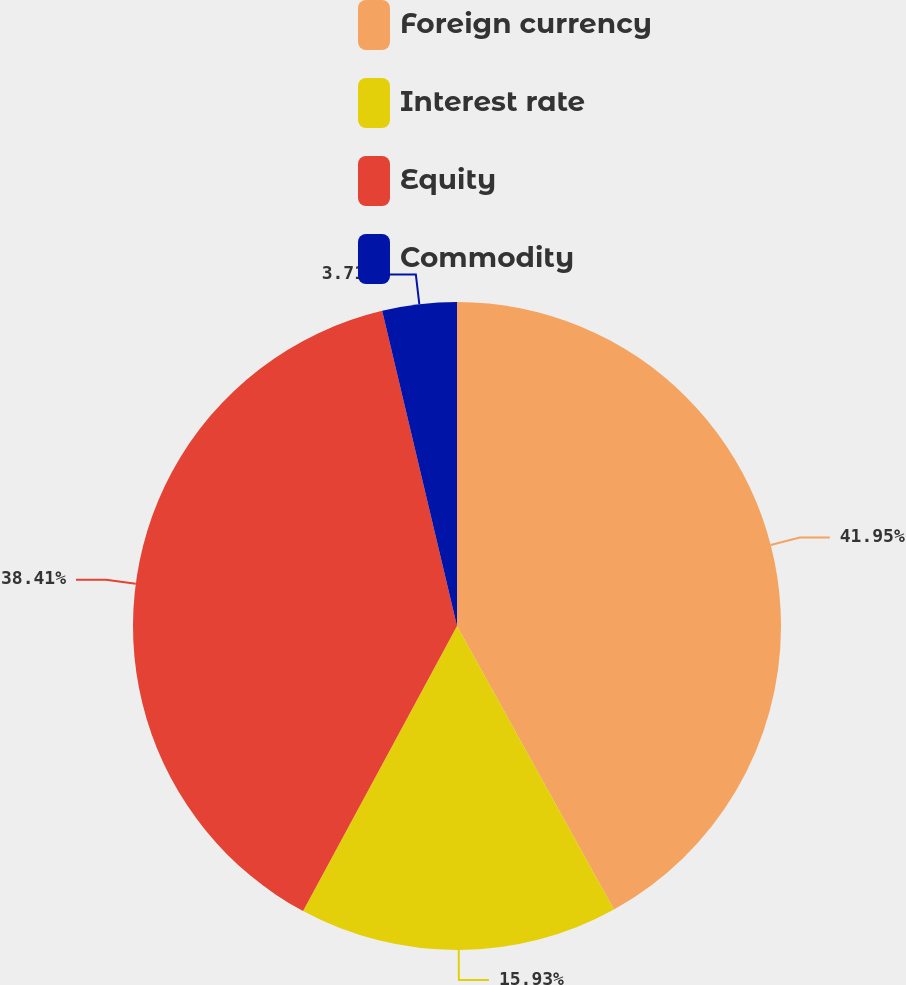Convert chart to OTSL. <chart><loc_0><loc_0><loc_500><loc_500><pie_chart><fcel>Foreign currency<fcel>Interest rate<fcel>Equity<fcel>Commodity<nl><fcel>41.95%<fcel>15.93%<fcel>38.41%<fcel>3.71%<nl></chart> 